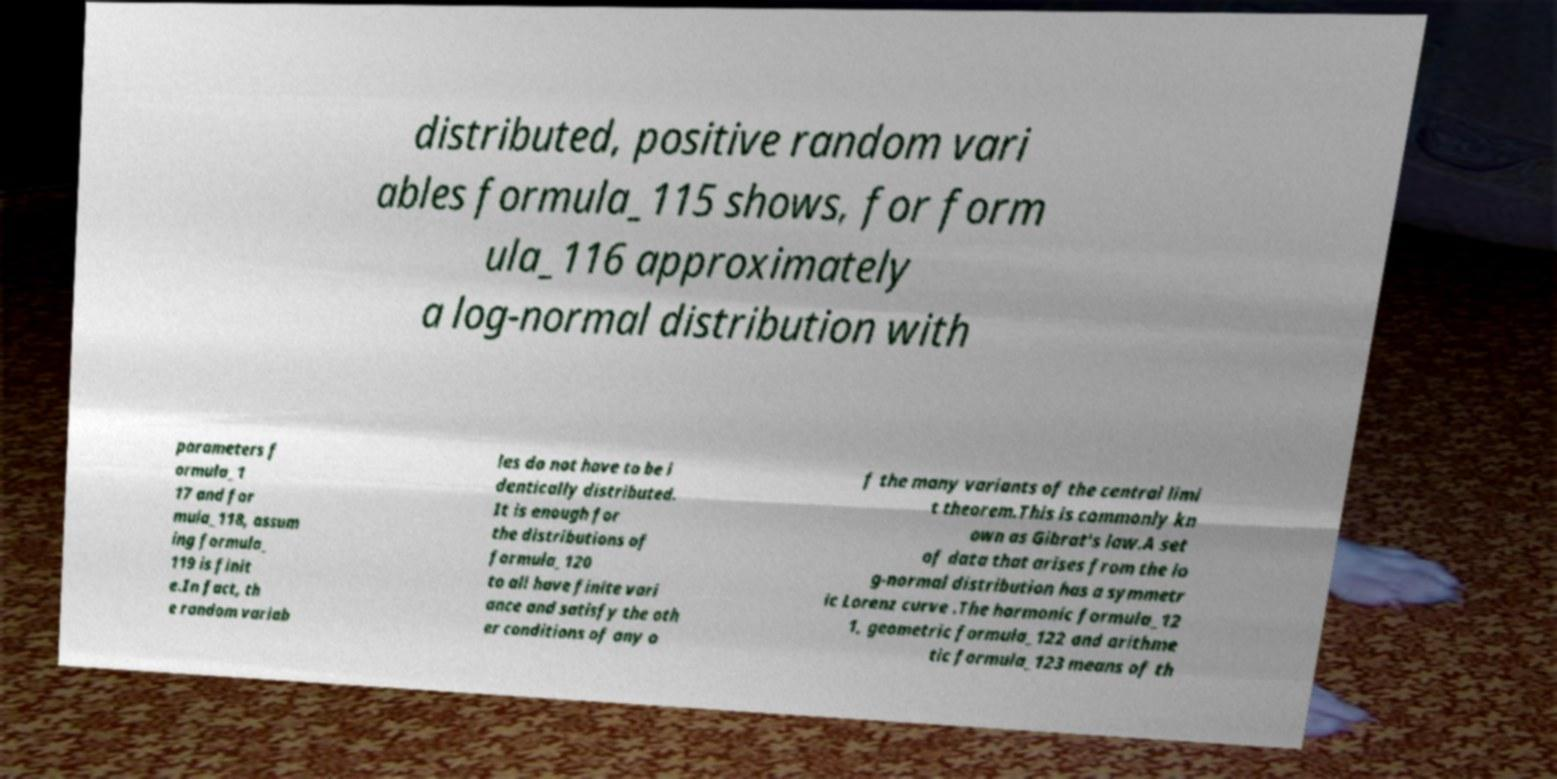Could you assist in decoding the text presented in this image and type it out clearly? distributed, positive random vari ables formula_115 shows, for form ula_116 approximately a log-normal distribution with parameters f ormula_1 17 and for mula_118, assum ing formula_ 119 is finit e.In fact, th e random variab les do not have to be i dentically distributed. It is enough for the distributions of formula_120 to all have finite vari ance and satisfy the oth er conditions of any o f the many variants of the central limi t theorem.This is commonly kn own as Gibrat's law.A set of data that arises from the lo g-normal distribution has a symmetr ic Lorenz curve .The harmonic formula_12 1, geometric formula_122 and arithme tic formula_123 means of th 